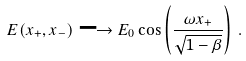Convert formula to latex. <formula><loc_0><loc_0><loc_500><loc_500>E ( x _ { + } , x _ { - } ) \longrightarrow E _ { 0 } \cos \left ( { \frac { \omega x _ { + } } { \sqrt { 1 - \beta } } } \right ) \, .</formula> 